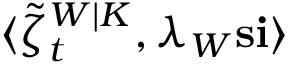<formula> <loc_0><loc_0><loc_500><loc_500>\langle \tilde { \zeta } _ { t } ^ { W | K } , \lambda _ { W } s i \rangle</formula> 